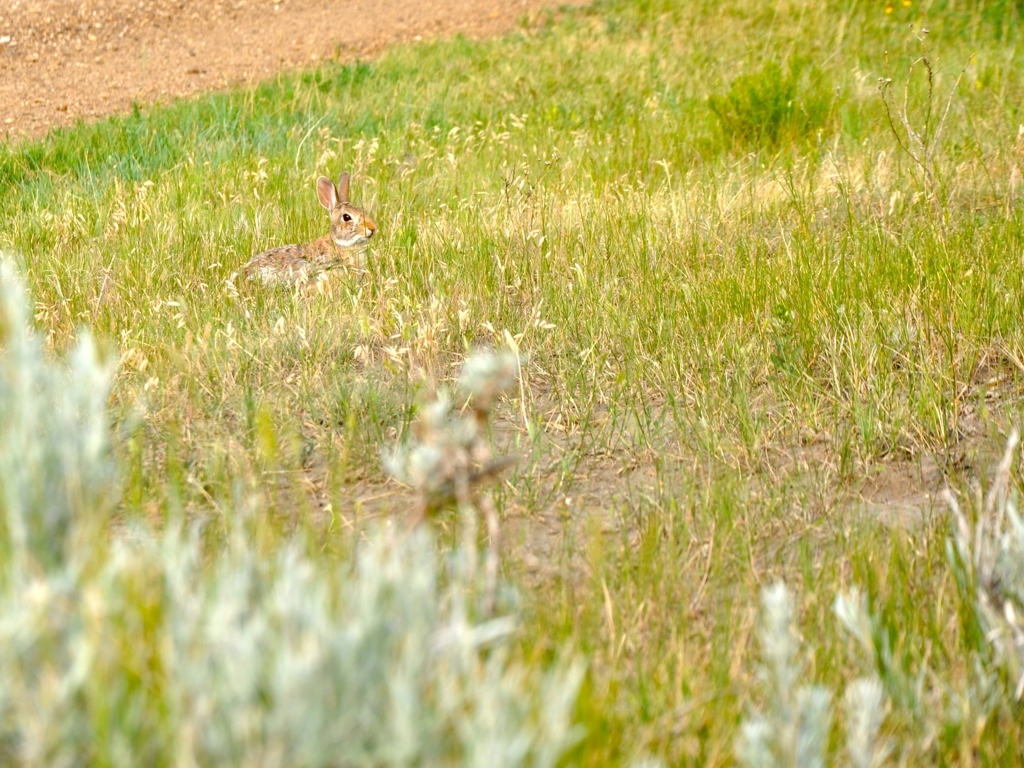Can you describe the setting and the time of day this photo might've been taken? The setting is a tranquil field with a mix of grass and small wildflowers, indicating a natural, open space. The quality of light and the shadows suggest this photo was taken on a bright day, possibly in the late morning or early afternoon when the sun is strong but not yet at its peak. Are there any indications of the season in the image? The vibrant green of the grass and the presence of wildflowers suggest that it's spring or early summer when plant life is abundant and in full bloom. 